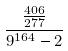Convert formula to latex. <formula><loc_0><loc_0><loc_500><loc_500>\frac { \frac { 4 0 6 } { 2 7 7 } } { 9 ^ { 1 6 4 } - 2 }</formula> 